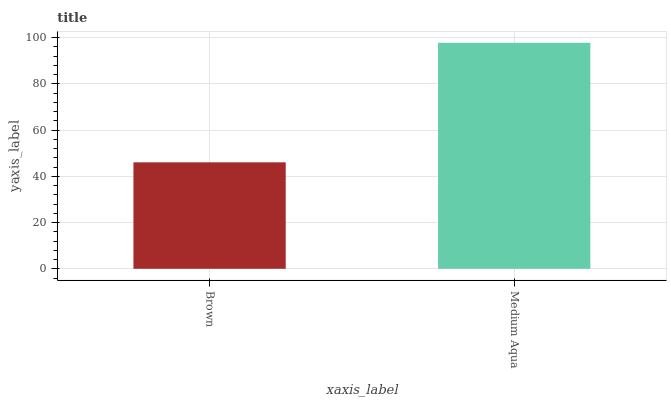Is Brown the minimum?
Answer yes or no. Yes. Is Medium Aqua the maximum?
Answer yes or no. Yes. Is Medium Aqua the minimum?
Answer yes or no. No. Is Medium Aqua greater than Brown?
Answer yes or no. Yes. Is Brown less than Medium Aqua?
Answer yes or no. Yes. Is Brown greater than Medium Aqua?
Answer yes or no. No. Is Medium Aqua less than Brown?
Answer yes or no. No. Is Medium Aqua the high median?
Answer yes or no. Yes. Is Brown the low median?
Answer yes or no. Yes. Is Brown the high median?
Answer yes or no. No. Is Medium Aqua the low median?
Answer yes or no. No. 